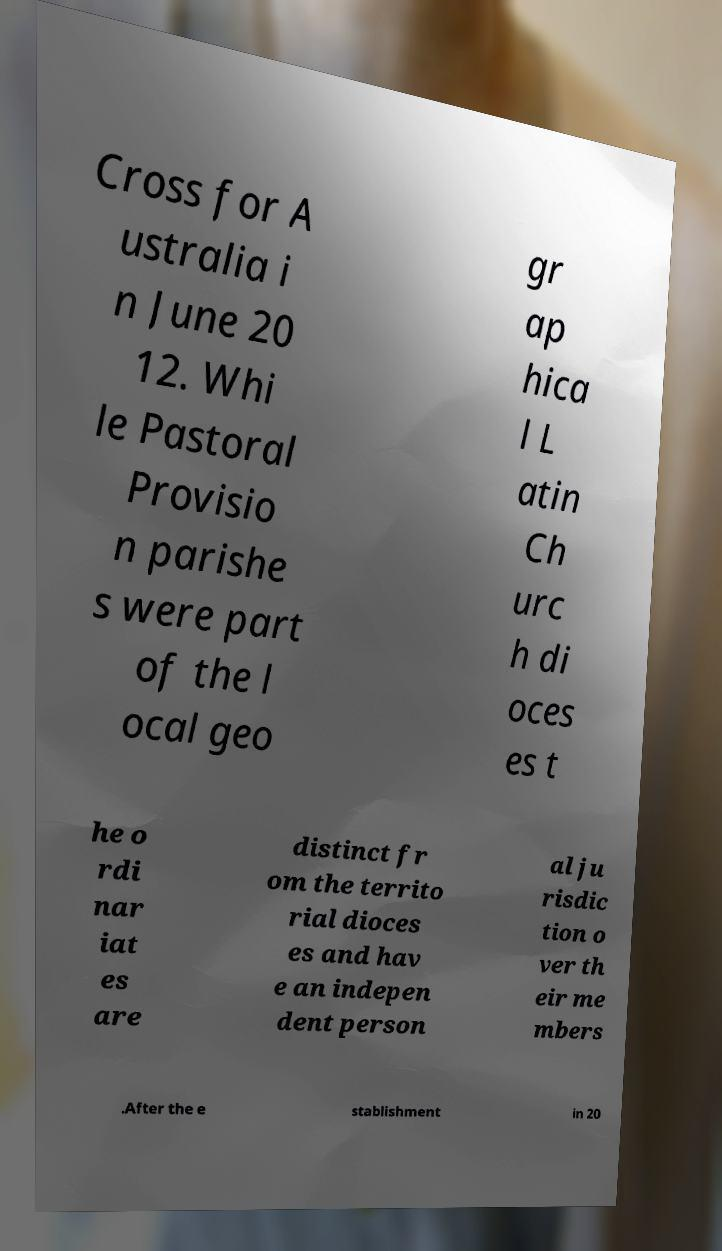Could you extract and type out the text from this image? Cross for A ustralia i n June 20 12. Whi le Pastoral Provisio n parishe s were part of the l ocal geo gr ap hica l L atin Ch urc h di oces es t he o rdi nar iat es are distinct fr om the territo rial dioces es and hav e an indepen dent person al ju risdic tion o ver th eir me mbers .After the e stablishment in 20 